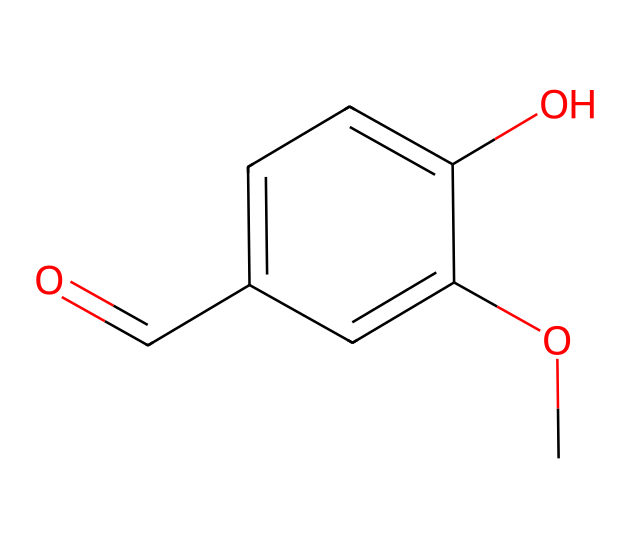What is the molecular formula of vanillin? To find the molecular formula, we count the atoms of each element from the provided SMILES representation. The structure has 8 carbon atoms, 8 hydrogen atoms, and 3 oxygen atoms. By combining them, the molecular formula is C8H8O3.
Answer: C8H8O3 How many hydroxyl groups are present in vanillin? Examining the structure, we look for hydroxyl groups (-OH). There is one hydroxyl group attached to a carbon atom in the aromatic ring of vanillin.
Answer: one What is the primary functional group in vanillin? The SMILES representation reveals that vanillin contains a carbonyl group (C=O) and a hydroxyl group (-OH). The carbonyl group is the primary functional group because it is part of the aldehyde structure at the end of the carbon chain.
Answer: carbonyl What characteristic of vanillin contributes to its aromatic flavor? The presence of an aromatic ring in the structure contributes significantly to the aromatic flavor of vanillin. The conjugated double bonds in the aromatic ring allow the chemical to interact with taste receptacles, providing a strong flavor profile.
Answer: aromatic ring What type of compound is vanillin classified as? Vanillin can be classified primarily as a phenolic compound due to the presence of the hydroxyl group attached to the aromatic system. It's also considered an aldehyde because it has the carbonyl functional group at the end of the chain.
Answer: phenolic compound How many total bonds are present in the vanillin molecule? By analyzing the structure, we notice that there are 12 total bonds: 8 C–C bonds and 4 C–H bonds. This includes all types of bonds present in the molecule.
Answer: twelve 